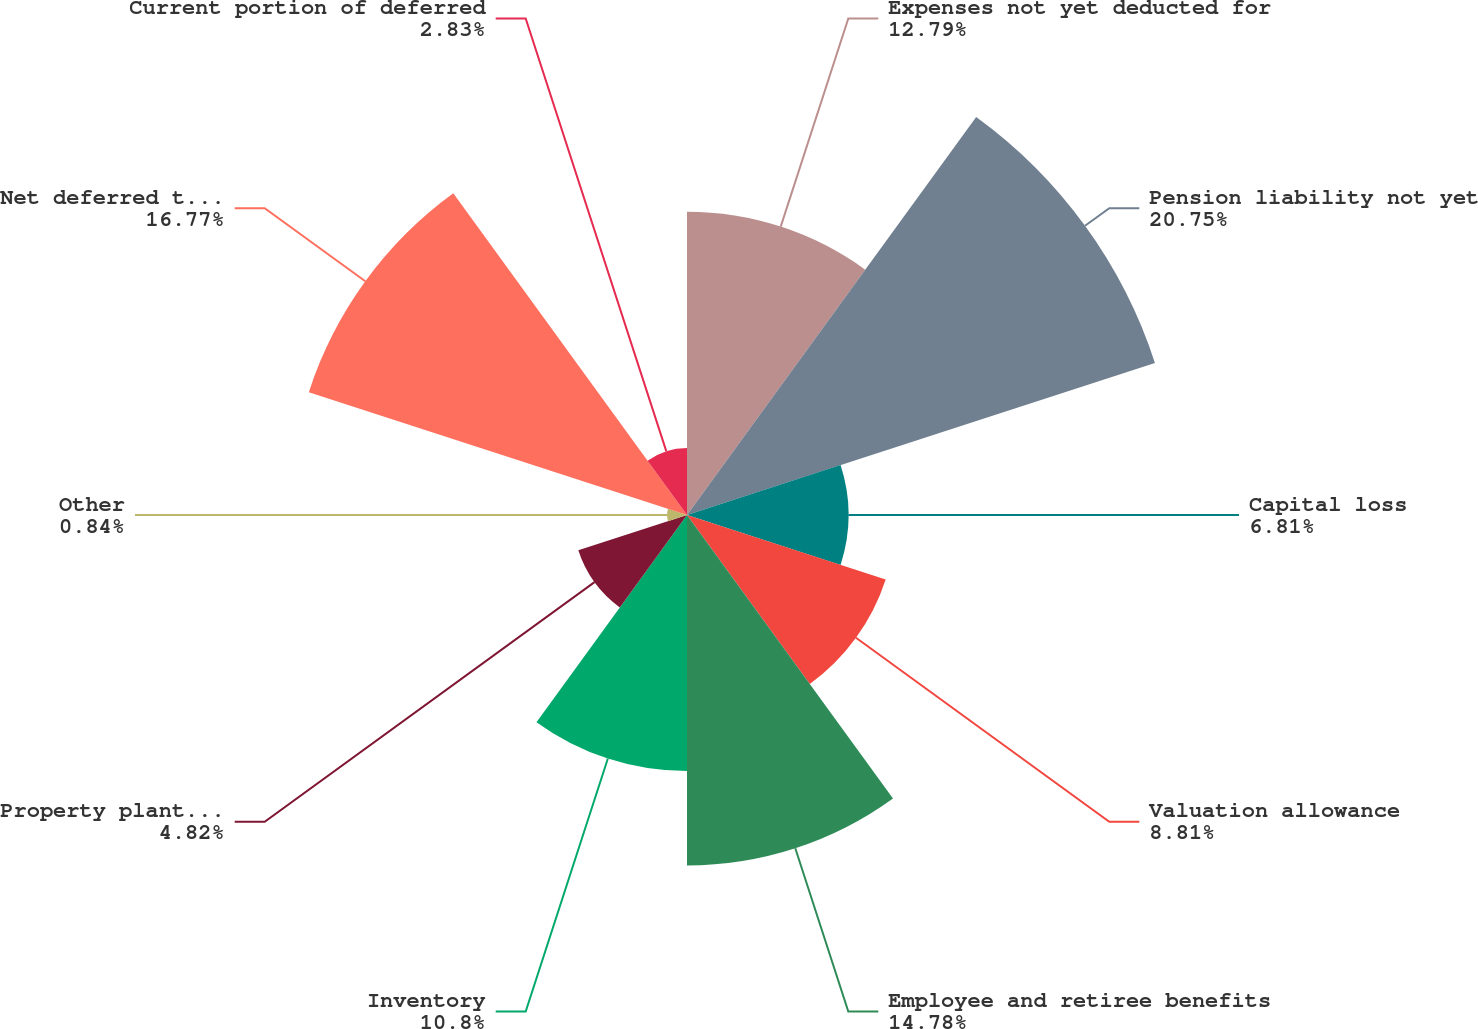<chart> <loc_0><loc_0><loc_500><loc_500><pie_chart><fcel>Expenses not yet deducted for<fcel>Pension liability not yet<fcel>Capital loss<fcel>Valuation allowance<fcel>Employee and retiree benefits<fcel>Inventory<fcel>Property plant and equipment<fcel>Other<fcel>Net deferred tax asset<fcel>Current portion of deferred<nl><fcel>12.79%<fcel>20.75%<fcel>6.81%<fcel>8.81%<fcel>14.78%<fcel>10.8%<fcel>4.82%<fcel>0.84%<fcel>16.77%<fcel>2.83%<nl></chart> 